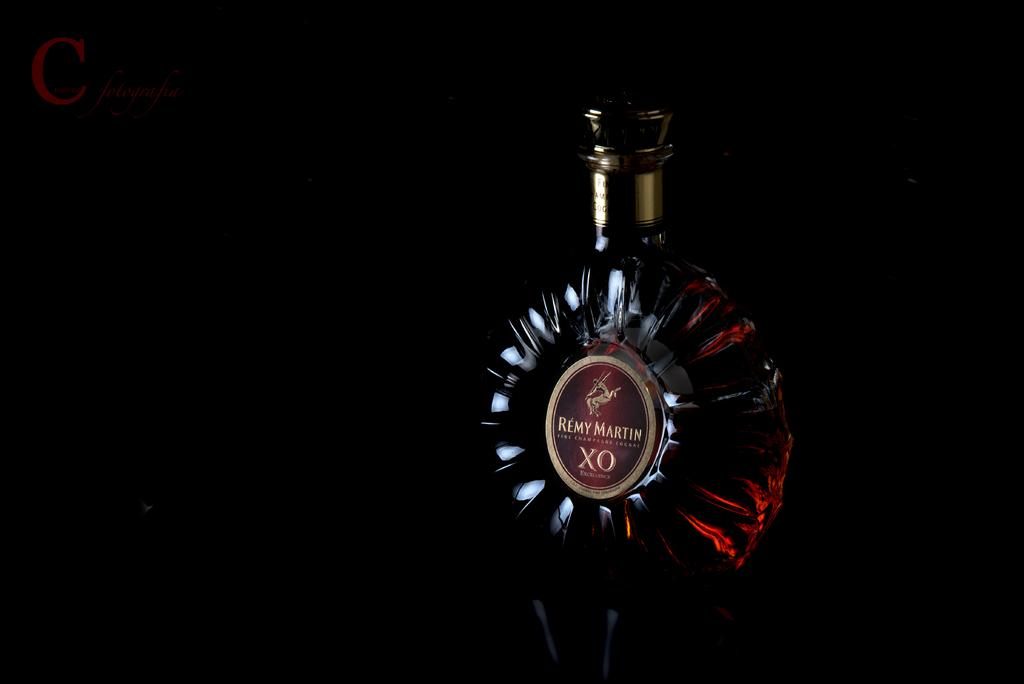What is the lighting condition in the image? The image is taken in a dark room. What can be seen on a bottle in the image? There is an alcohol bottle in the image. What is on the bottle that provides information about its contents? There is a sticker on the bottle, and it has the text "REMY MARTIN" on it. What type of nation is depicted on the sticker of the bottle? There is no nation depicted on the sticker of the bottle; it only has the text "REMY MARTIN." What type of spoon is used to stir the contents of the bottle? There is no spoon present in the image, as it features an alcohol bottle with a sticker. 